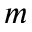Convert formula to latex. <formula><loc_0><loc_0><loc_500><loc_500>m</formula> 